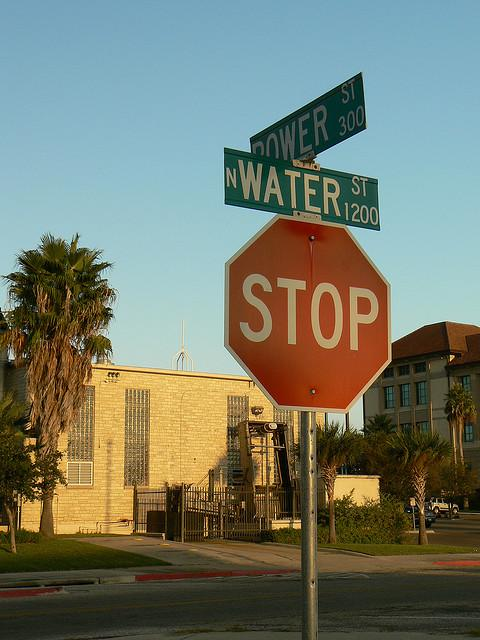What is next to the building?

Choices:
A) trees
B) horse
C) antelope
D) cow trees 